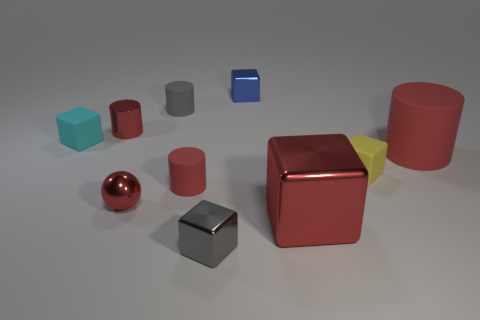Are there fewer small metallic balls behind the big red rubber object than gray shiny things in front of the gray metallic block?
Your response must be concise. No. What is the size of the rubber object that is both behind the large cylinder and on the right side of the cyan thing?
Provide a succinct answer. Small. There is a small gray thing behind the tiny red metallic object that is in front of the cyan object; are there any small yellow rubber blocks to the left of it?
Your response must be concise. No. Is there a small brown matte object?
Your answer should be compact. No. Are there more large matte objects in front of the red cube than blue objects in front of the cyan thing?
Give a very brief answer. No. The yellow object that is made of the same material as the tiny cyan block is what size?
Offer a very short reply. Small. There is a red rubber cylinder left of the big red shiny cube that is in front of the tiny gray cylinder that is behind the gray block; what is its size?
Provide a short and direct response. Small. The tiny block that is in front of the tiny red rubber cylinder is what color?
Offer a terse response. Gray. Are there more large metallic cubes that are behind the cyan rubber cube than metallic spheres?
Your response must be concise. No. Is the shape of the tiny gray thing that is behind the tiny yellow matte cube the same as  the big matte thing?
Offer a very short reply. Yes. 